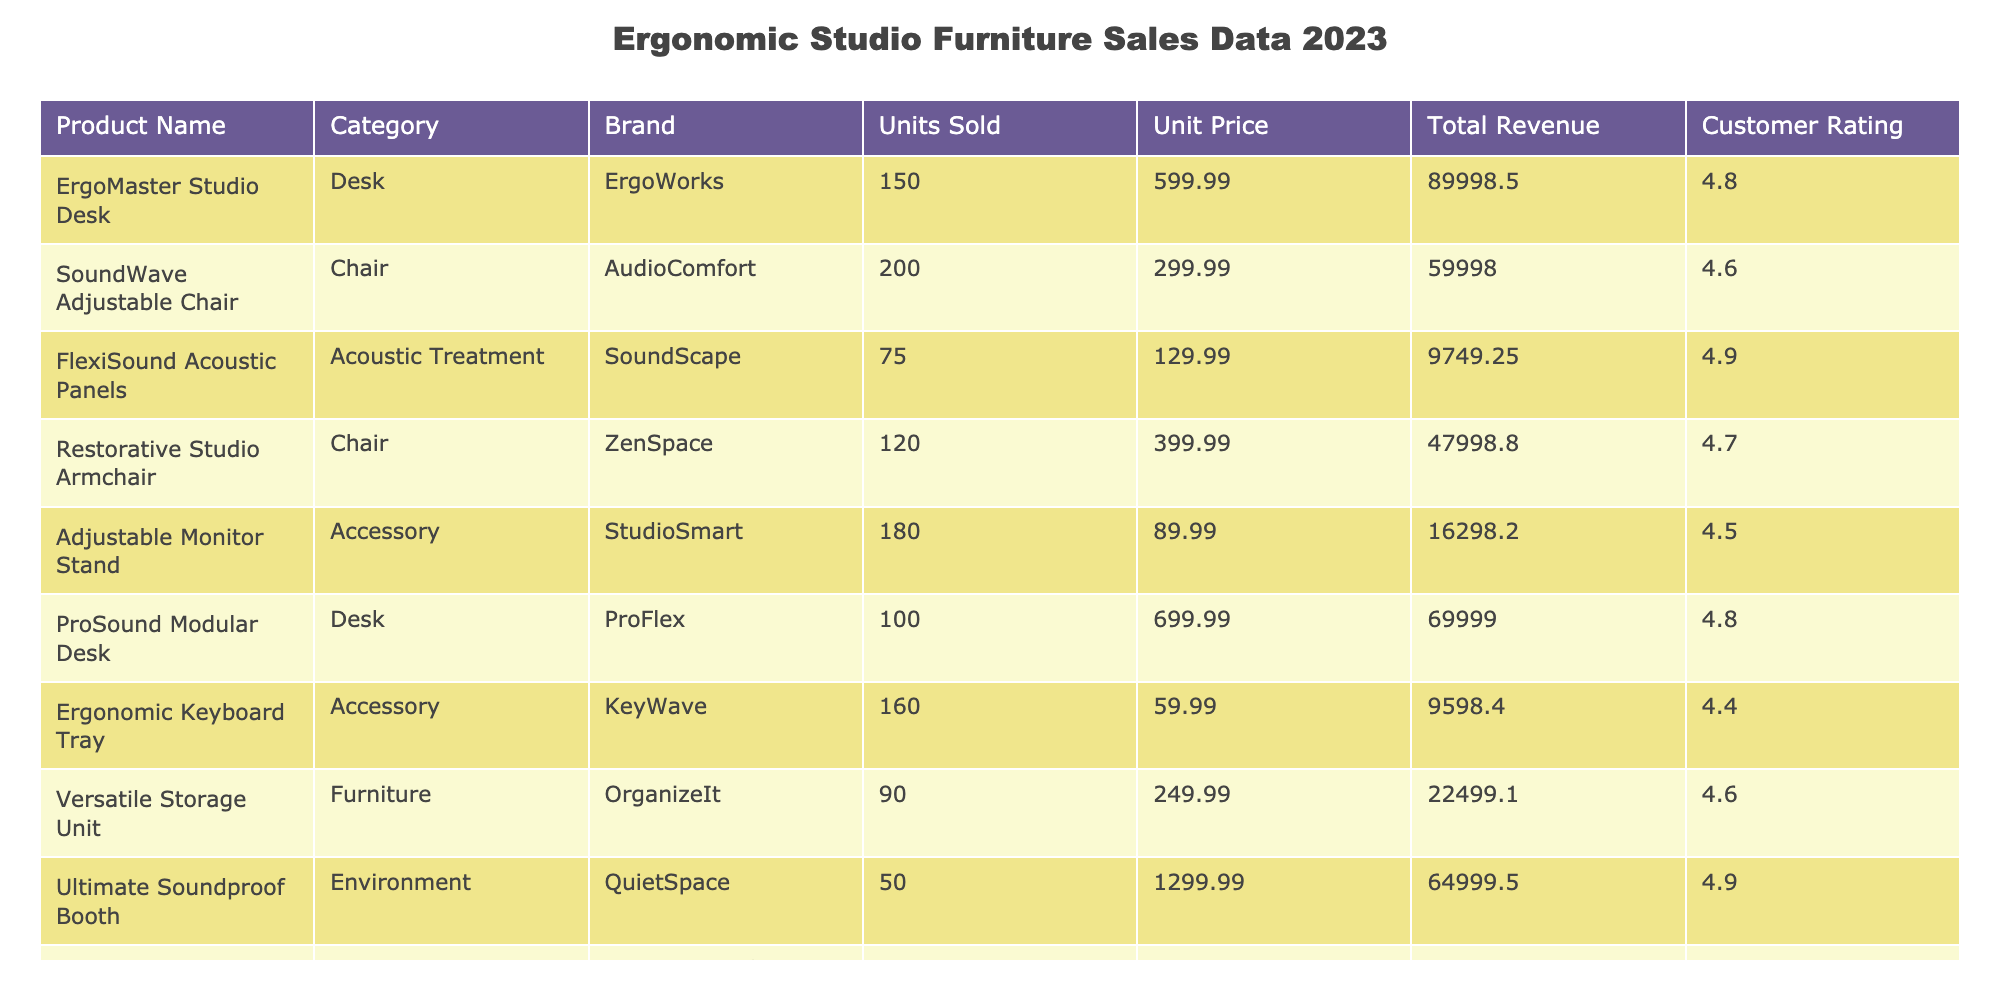What is the total revenue generated from the ErgoMaster Studio Desk? The Total Revenue for the ErgoMaster Studio Desk is listed in the table as 89998.50.
Answer: 89998.50 Which product has the highest customer rating? The customer ratings are compared across the table, and the highest rating is 4.9, which is associated with both the FlexiSound Acoustic Panels and the Ultimate Soundproof Booth.
Answer: FlexiSound Acoustic Panels and Ultimate Soundproof Booth What is the average unit price of all the chairs listed? The unit prices for the chairs (299.99, 399.99, and 149.99) are summed up (299.99 + 399.99 + 149.99 = 849.97) and then divided by the number of chairs (3), resulting in an average of 849.97 / 3 = 283.32.
Answer: 283.32 Did the Adjustable Monitor Stand generate more revenue than the Restorative Studio Armchair? The Total Revenue for the Adjustable Monitor Stand is 16298.20, and for the Restorative Studio Armchair, it is 47998.80. Since 16298.20 is less than 47998.80, the statement is false.
Answer: No What is the total number of units sold across all products in the table? All units sold are summed: (150 + 200 + 75 + 120 + 180 + 100 + 160 + 90 + 50 + 130 = 1105).
Answer: 1105 Which chair generated the most revenue? The revenue for each chair is calculated: SoundWave Adjustable Chair (59998.00) and Restorative Studio Armchair (47998.80). Since 59998.00 is greater, the SoundWave Adjustable Chair generated the most revenue.
Answer: SoundWave Adjustable Chair What is the difference in revenue between the ProSound Modular Desk and the ErgoMaster Studio Desk? The Total Revenue for the ProSound Modular Desk is 69999.00 and for the ErgoMaster Studio Desk is 89998.50. The difference is 89998.50 - 69999.00 = 19999.50.
Answer: 19999.50 Is the total revenue from the FlexiSound Acoustic Panels greater than the total revenue from the Versatile Storage Unit? The Total Revenue for the FlexiSound Acoustic Panels is 9749.25 and for the Versatile Storage Unit is 22499.10. Since 9749.25 is less than 22499.10, the statement is false.
Answer: No 